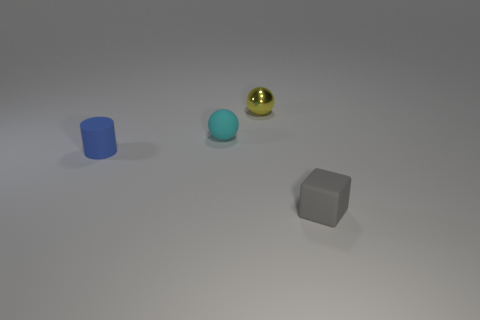Add 2 blue cylinders. How many objects exist? 6 Subtract all blocks. How many objects are left? 3 Add 1 small cyan things. How many small cyan things are left? 2 Add 4 gray rubber cubes. How many gray rubber cubes exist? 5 Subtract 0 blue cubes. How many objects are left? 4 Subtract all small cyan shiny cylinders. Subtract all yellow things. How many objects are left? 3 